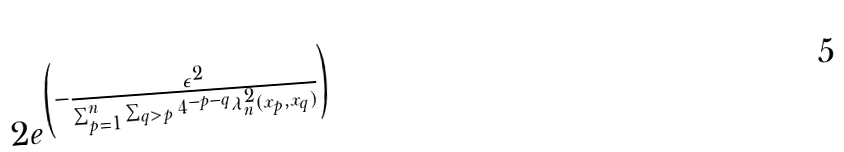<formula> <loc_0><loc_0><loc_500><loc_500>2 e ^ { \left ( - \frac { \epsilon ^ { 2 } } { \sum _ { p = 1 } ^ { n } { \sum _ { q > p } { 4 ^ { - p - q } \lambda ^ { 2 } _ { n } ( x _ { p } , x _ { q } ) } } } \right ) }</formula> 